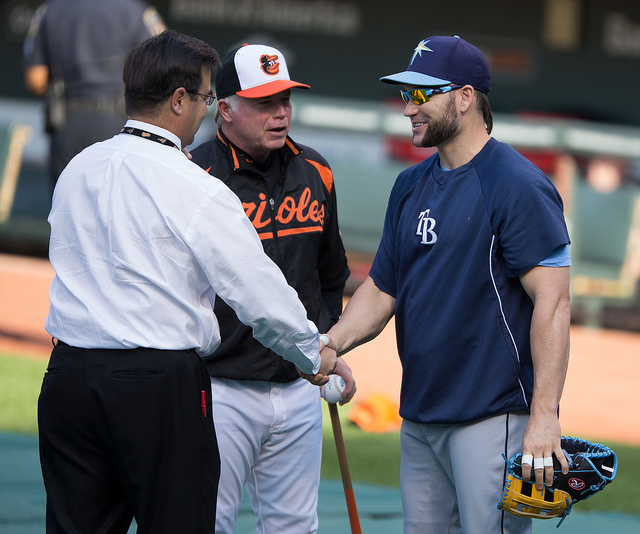Identify the text displayed in this image. Orioles 